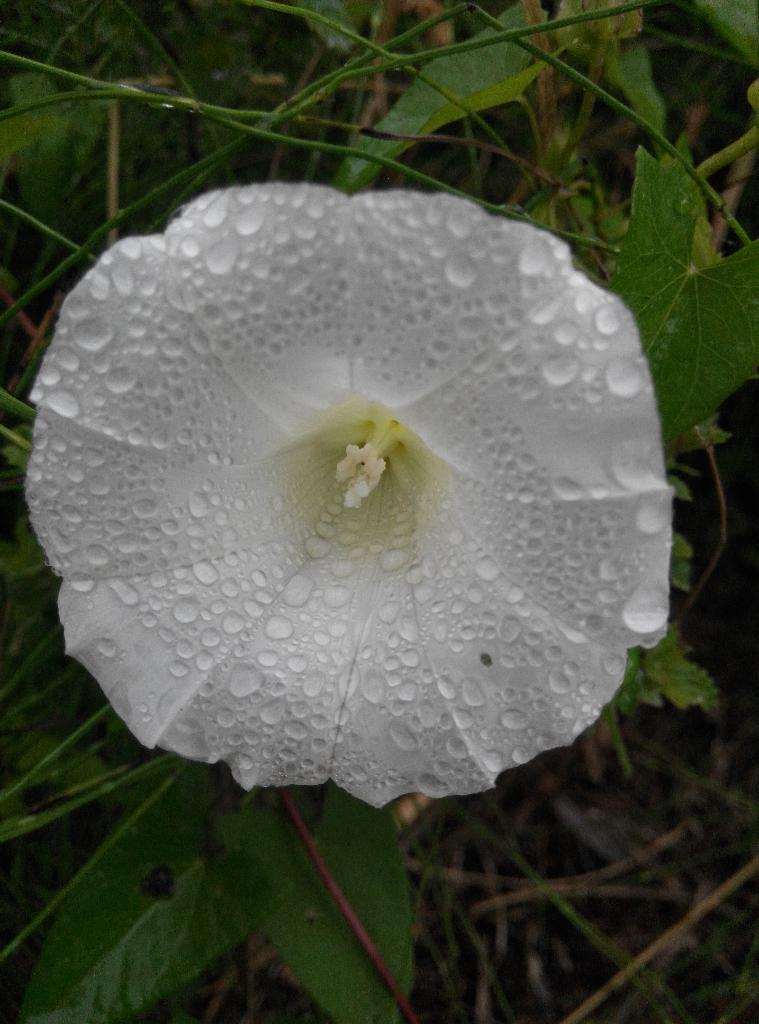What is the main subject of the image? There is a flower in the image. Can you describe the color of the flower? The flower is white. What else can be seen in the background of the image? There are plants in the background of the image. What type of news can be seen on the pocket of the skirt in the image? There is no pocket or skirt present in the image; it features a white flower and plants in the background. 